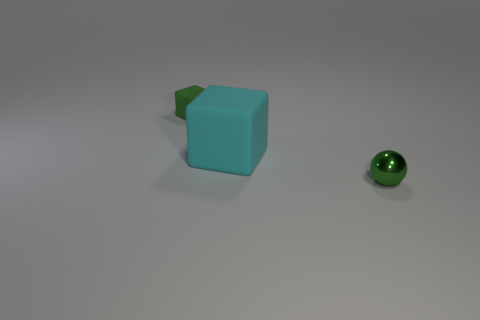Add 3 cyan matte blocks. How many objects exist? 6 Subtract all balls. How many objects are left? 2 Subtract all tiny green rubber objects. Subtract all green matte things. How many objects are left? 1 Add 1 metallic balls. How many metallic balls are left? 2 Add 2 small rubber cylinders. How many small rubber cylinders exist? 2 Subtract 0 gray cubes. How many objects are left? 3 